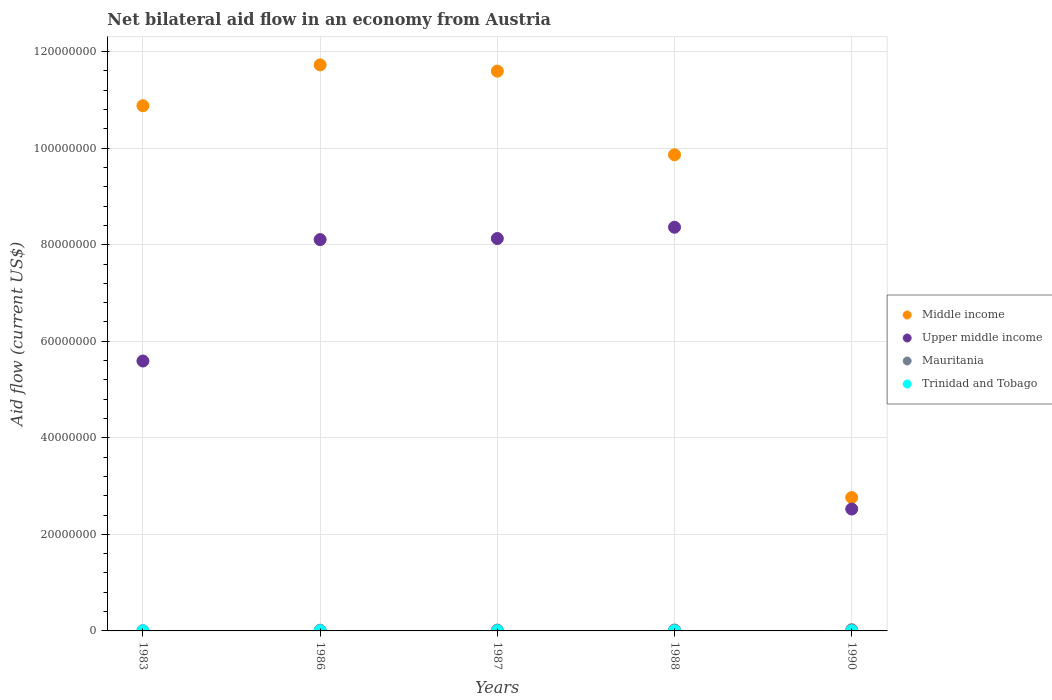How many different coloured dotlines are there?
Your answer should be very brief. 4. Is the number of dotlines equal to the number of legend labels?
Ensure brevity in your answer.  Yes. What is the net bilateral aid flow in Middle income in 1988?
Provide a short and direct response. 9.86e+07. Across all years, what is the maximum net bilateral aid flow in Middle income?
Make the answer very short. 1.17e+08. In which year was the net bilateral aid flow in Upper middle income maximum?
Your answer should be compact. 1988. What is the total net bilateral aid flow in Mauritania in the graph?
Make the answer very short. 8.20e+05. What is the difference between the net bilateral aid flow in Middle income in 1987 and that in 1990?
Provide a succinct answer. 8.83e+07. What is the difference between the net bilateral aid flow in Middle income in 1983 and the net bilateral aid flow in Mauritania in 1987?
Your answer should be very brief. 1.09e+08. What is the average net bilateral aid flow in Trinidad and Tobago per year?
Offer a very short reply. 1.60e+04. In the year 1990, what is the difference between the net bilateral aid flow in Trinidad and Tobago and net bilateral aid flow in Mauritania?
Your answer should be compact. -2.40e+05. What is the ratio of the net bilateral aid flow in Middle income in 1983 to that in 1986?
Make the answer very short. 0.93. Is the difference between the net bilateral aid flow in Trinidad and Tobago in 1987 and 1990 greater than the difference between the net bilateral aid flow in Mauritania in 1987 and 1990?
Offer a very short reply. Yes. What is the difference between the highest and the lowest net bilateral aid flow in Upper middle income?
Offer a very short reply. 5.84e+07. In how many years, is the net bilateral aid flow in Mauritania greater than the average net bilateral aid flow in Mauritania taken over all years?
Your answer should be compact. 3. Is it the case that in every year, the sum of the net bilateral aid flow in Upper middle income and net bilateral aid flow in Mauritania  is greater than the sum of net bilateral aid flow in Trinidad and Tobago and net bilateral aid flow in Middle income?
Offer a very short reply. Yes. Is it the case that in every year, the sum of the net bilateral aid flow in Upper middle income and net bilateral aid flow in Trinidad and Tobago  is greater than the net bilateral aid flow in Mauritania?
Your response must be concise. Yes. Does the net bilateral aid flow in Trinidad and Tobago monotonically increase over the years?
Offer a terse response. No. Is the net bilateral aid flow in Mauritania strictly less than the net bilateral aid flow in Upper middle income over the years?
Give a very brief answer. Yes. How many years are there in the graph?
Keep it short and to the point. 5. Are the values on the major ticks of Y-axis written in scientific E-notation?
Offer a terse response. No. Does the graph contain any zero values?
Provide a succinct answer. No. How many legend labels are there?
Make the answer very short. 4. What is the title of the graph?
Provide a succinct answer. Net bilateral aid flow in an economy from Austria. Does "High income" appear as one of the legend labels in the graph?
Provide a short and direct response. No. What is the label or title of the Y-axis?
Ensure brevity in your answer.  Aid flow (current US$). What is the Aid flow (current US$) in Middle income in 1983?
Your response must be concise. 1.09e+08. What is the Aid flow (current US$) in Upper middle income in 1983?
Ensure brevity in your answer.  5.59e+07. What is the Aid flow (current US$) of Middle income in 1986?
Your answer should be very brief. 1.17e+08. What is the Aid flow (current US$) in Upper middle income in 1986?
Your answer should be very brief. 8.11e+07. What is the Aid flow (current US$) in Mauritania in 1986?
Your answer should be very brief. 1.50e+05. What is the Aid flow (current US$) of Trinidad and Tobago in 1986?
Offer a very short reply. 3.00e+04. What is the Aid flow (current US$) of Middle income in 1987?
Your answer should be compact. 1.16e+08. What is the Aid flow (current US$) of Upper middle income in 1987?
Provide a short and direct response. 8.13e+07. What is the Aid flow (current US$) of Mauritania in 1987?
Ensure brevity in your answer.  1.80e+05. What is the Aid flow (current US$) in Middle income in 1988?
Provide a short and direct response. 9.86e+07. What is the Aid flow (current US$) of Upper middle income in 1988?
Your answer should be very brief. 8.36e+07. What is the Aid flow (current US$) in Mauritania in 1988?
Your answer should be compact. 1.90e+05. What is the Aid flow (current US$) of Trinidad and Tobago in 1988?
Keep it short and to the point. 10000. What is the Aid flow (current US$) of Middle income in 1990?
Give a very brief answer. 2.76e+07. What is the Aid flow (current US$) in Upper middle income in 1990?
Offer a terse response. 2.52e+07. What is the Aid flow (current US$) of Mauritania in 1990?
Keep it short and to the point. 2.50e+05. What is the Aid flow (current US$) of Trinidad and Tobago in 1990?
Your response must be concise. 10000. Across all years, what is the maximum Aid flow (current US$) in Middle income?
Ensure brevity in your answer.  1.17e+08. Across all years, what is the maximum Aid flow (current US$) of Upper middle income?
Your answer should be compact. 8.36e+07. Across all years, what is the maximum Aid flow (current US$) of Mauritania?
Your response must be concise. 2.50e+05. Across all years, what is the minimum Aid flow (current US$) in Middle income?
Offer a terse response. 2.76e+07. Across all years, what is the minimum Aid flow (current US$) of Upper middle income?
Provide a succinct answer. 2.52e+07. Across all years, what is the minimum Aid flow (current US$) in Mauritania?
Your answer should be compact. 5.00e+04. What is the total Aid flow (current US$) of Middle income in the graph?
Give a very brief answer. 4.68e+08. What is the total Aid flow (current US$) in Upper middle income in the graph?
Keep it short and to the point. 3.27e+08. What is the total Aid flow (current US$) in Mauritania in the graph?
Your answer should be very brief. 8.20e+05. What is the total Aid flow (current US$) in Trinidad and Tobago in the graph?
Provide a short and direct response. 8.00e+04. What is the difference between the Aid flow (current US$) in Middle income in 1983 and that in 1986?
Your answer should be very brief. -8.46e+06. What is the difference between the Aid flow (current US$) of Upper middle income in 1983 and that in 1986?
Your answer should be very brief. -2.52e+07. What is the difference between the Aid flow (current US$) in Mauritania in 1983 and that in 1986?
Offer a very short reply. -1.00e+05. What is the difference between the Aid flow (current US$) in Trinidad and Tobago in 1983 and that in 1986?
Give a very brief answer. -2.00e+04. What is the difference between the Aid flow (current US$) in Middle income in 1983 and that in 1987?
Provide a short and direct response. -7.16e+06. What is the difference between the Aid flow (current US$) of Upper middle income in 1983 and that in 1987?
Offer a terse response. -2.54e+07. What is the difference between the Aid flow (current US$) in Trinidad and Tobago in 1983 and that in 1987?
Keep it short and to the point. -10000. What is the difference between the Aid flow (current US$) in Middle income in 1983 and that in 1988?
Keep it short and to the point. 1.02e+07. What is the difference between the Aid flow (current US$) of Upper middle income in 1983 and that in 1988?
Give a very brief answer. -2.77e+07. What is the difference between the Aid flow (current US$) of Mauritania in 1983 and that in 1988?
Your answer should be compact. -1.40e+05. What is the difference between the Aid flow (current US$) in Trinidad and Tobago in 1983 and that in 1988?
Keep it short and to the point. 0. What is the difference between the Aid flow (current US$) in Middle income in 1983 and that in 1990?
Your answer should be compact. 8.12e+07. What is the difference between the Aid flow (current US$) in Upper middle income in 1983 and that in 1990?
Give a very brief answer. 3.07e+07. What is the difference between the Aid flow (current US$) of Mauritania in 1983 and that in 1990?
Give a very brief answer. -2.00e+05. What is the difference between the Aid flow (current US$) of Middle income in 1986 and that in 1987?
Your answer should be compact. 1.30e+06. What is the difference between the Aid flow (current US$) of Upper middle income in 1986 and that in 1987?
Ensure brevity in your answer.  -2.20e+05. What is the difference between the Aid flow (current US$) of Middle income in 1986 and that in 1988?
Your answer should be very brief. 1.86e+07. What is the difference between the Aid flow (current US$) of Upper middle income in 1986 and that in 1988?
Provide a short and direct response. -2.56e+06. What is the difference between the Aid flow (current US$) of Trinidad and Tobago in 1986 and that in 1988?
Offer a very short reply. 2.00e+04. What is the difference between the Aid flow (current US$) of Middle income in 1986 and that in 1990?
Make the answer very short. 8.96e+07. What is the difference between the Aid flow (current US$) in Upper middle income in 1986 and that in 1990?
Keep it short and to the point. 5.58e+07. What is the difference between the Aid flow (current US$) in Trinidad and Tobago in 1986 and that in 1990?
Keep it short and to the point. 2.00e+04. What is the difference between the Aid flow (current US$) in Middle income in 1987 and that in 1988?
Your response must be concise. 1.73e+07. What is the difference between the Aid flow (current US$) of Upper middle income in 1987 and that in 1988?
Give a very brief answer. -2.34e+06. What is the difference between the Aid flow (current US$) of Mauritania in 1987 and that in 1988?
Offer a terse response. -10000. What is the difference between the Aid flow (current US$) of Middle income in 1987 and that in 1990?
Your answer should be compact. 8.83e+07. What is the difference between the Aid flow (current US$) in Upper middle income in 1987 and that in 1990?
Your response must be concise. 5.60e+07. What is the difference between the Aid flow (current US$) in Mauritania in 1987 and that in 1990?
Offer a terse response. -7.00e+04. What is the difference between the Aid flow (current US$) of Trinidad and Tobago in 1987 and that in 1990?
Keep it short and to the point. 10000. What is the difference between the Aid flow (current US$) of Middle income in 1988 and that in 1990?
Offer a very short reply. 7.10e+07. What is the difference between the Aid flow (current US$) in Upper middle income in 1988 and that in 1990?
Keep it short and to the point. 5.84e+07. What is the difference between the Aid flow (current US$) in Mauritania in 1988 and that in 1990?
Your answer should be compact. -6.00e+04. What is the difference between the Aid flow (current US$) in Middle income in 1983 and the Aid flow (current US$) in Upper middle income in 1986?
Ensure brevity in your answer.  2.77e+07. What is the difference between the Aid flow (current US$) of Middle income in 1983 and the Aid flow (current US$) of Mauritania in 1986?
Offer a very short reply. 1.09e+08. What is the difference between the Aid flow (current US$) in Middle income in 1983 and the Aid flow (current US$) in Trinidad and Tobago in 1986?
Make the answer very short. 1.09e+08. What is the difference between the Aid flow (current US$) of Upper middle income in 1983 and the Aid flow (current US$) of Mauritania in 1986?
Your response must be concise. 5.58e+07. What is the difference between the Aid flow (current US$) of Upper middle income in 1983 and the Aid flow (current US$) of Trinidad and Tobago in 1986?
Keep it short and to the point. 5.59e+07. What is the difference between the Aid flow (current US$) in Middle income in 1983 and the Aid flow (current US$) in Upper middle income in 1987?
Give a very brief answer. 2.75e+07. What is the difference between the Aid flow (current US$) of Middle income in 1983 and the Aid flow (current US$) of Mauritania in 1987?
Give a very brief answer. 1.09e+08. What is the difference between the Aid flow (current US$) in Middle income in 1983 and the Aid flow (current US$) in Trinidad and Tobago in 1987?
Provide a succinct answer. 1.09e+08. What is the difference between the Aid flow (current US$) in Upper middle income in 1983 and the Aid flow (current US$) in Mauritania in 1987?
Your answer should be compact. 5.57e+07. What is the difference between the Aid flow (current US$) in Upper middle income in 1983 and the Aid flow (current US$) in Trinidad and Tobago in 1987?
Offer a terse response. 5.59e+07. What is the difference between the Aid flow (current US$) in Mauritania in 1983 and the Aid flow (current US$) in Trinidad and Tobago in 1987?
Provide a short and direct response. 3.00e+04. What is the difference between the Aid flow (current US$) in Middle income in 1983 and the Aid flow (current US$) in Upper middle income in 1988?
Give a very brief answer. 2.52e+07. What is the difference between the Aid flow (current US$) in Middle income in 1983 and the Aid flow (current US$) in Mauritania in 1988?
Provide a succinct answer. 1.09e+08. What is the difference between the Aid flow (current US$) in Middle income in 1983 and the Aid flow (current US$) in Trinidad and Tobago in 1988?
Provide a succinct answer. 1.09e+08. What is the difference between the Aid flow (current US$) of Upper middle income in 1983 and the Aid flow (current US$) of Mauritania in 1988?
Offer a very short reply. 5.57e+07. What is the difference between the Aid flow (current US$) in Upper middle income in 1983 and the Aid flow (current US$) in Trinidad and Tobago in 1988?
Provide a short and direct response. 5.59e+07. What is the difference between the Aid flow (current US$) of Middle income in 1983 and the Aid flow (current US$) of Upper middle income in 1990?
Make the answer very short. 8.35e+07. What is the difference between the Aid flow (current US$) of Middle income in 1983 and the Aid flow (current US$) of Mauritania in 1990?
Keep it short and to the point. 1.09e+08. What is the difference between the Aid flow (current US$) in Middle income in 1983 and the Aid flow (current US$) in Trinidad and Tobago in 1990?
Offer a very short reply. 1.09e+08. What is the difference between the Aid flow (current US$) of Upper middle income in 1983 and the Aid flow (current US$) of Mauritania in 1990?
Offer a terse response. 5.57e+07. What is the difference between the Aid flow (current US$) in Upper middle income in 1983 and the Aid flow (current US$) in Trinidad and Tobago in 1990?
Give a very brief answer. 5.59e+07. What is the difference between the Aid flow (current US$) in Middle income in 1986 and the Aid flow (current US$) in Upper middle income in 1987?
Offer a terse response. 3.60e+07. What is the difference between the Aid flow (current US$) in Middle income in 1986 and the Aid flow (current US$) in Mauritania in 1987?
Your answer should be compact. 1.17e+08. What is the difference between the Aid flow (current US$) in Middle income in 1986 and the Aid flow (current US$) in Trinidad and Tobago in 1987?
Keep it short and to the point. 1.17e+08. What is the difference between the Aid flow (current US$) in Upper middle income in 1986 and the Aid flow (current US$) in Mauritania in 1987?
Provide a succinct answer. 8.09e+07. What is the difference between the Aid flow (current US$) of Upper middle income in 1986 and the Aid flow (current US$) of Trinidad and Tobago in 1987?
Provide a short and direct response. 8.10e+07. What is the difference between the Aid flow (current US$) in Mauritania in 1986 and the Aid flow (current US$) in Trinidad and Tobago in 1987?
Your answer should be very brief. 1.30e+05. What is the difference between the Aid flow (current US$) in Middle income in 1986 and the Aid flow (current US$) in Upper middle income in 1988?
Make the answer very short. 3.36e+07. What is the difference between the Aid flow (current US$) in Middle income in 1986 and the Aid flow (current US$) in Mauritania in 1988?
Provide a succinct answer. 1.17e+08. What is the difference between the Aid flow (current US$) of Middle income in 1986 and the Aid flow (current US$) of Trinidad and Tobago in 1988?
Offer a terse response. 1.17e+08. What is the difference between the Aid flow (current US$) of Upper middle income in 1986 and the Aid flow (current US$) of Mauritania in 1988?
Your answer should be compact. 8.09e+07. What is the difference between the Aid flow (current US$) in Upper middle income in 1986 and the Aid flow (current US$) in Trinidad and Tobago in 1988?
Give a very brief answer. 8.10e+07. What is the difference between the Aid flow (current US$) of Mauritania in 1986 and the Aid flow (current US$) of Trinidad and Tobago in 1988?
Keep it short and to the point. 1.40e+05. What is the difference between the Aid flow (current US$) in Middle income in 1986 and the Aid flow (current US$) in Upper middle income in 1990?
Make the answer very short. 9.20e+07. What is the difference between the Aid flow (current US$) of Middle income in 1986 and the Aid flow (current US$) of Mauritania in 1990?
Your response must be concise. 1.17e+08. What is the difference between the Aid flow (current US$) of Middle income in 1986 and the Aid flow (current US$) of Trinidad and Tobago in 1990?
Ensure brevity in your answer.  1.17e+08. What is the difference between the Aid flow (current US$) in Upper middle income in 1986 and the Aid flow (current US$) in Mauritania in 1990?
Ensure brevity in your answer.  8.08e+07. What is the difference between the Aid flow (current US$) of Upper middle income in 1986 and the Aid flow (current US$) of Trinidad and Tobago in 1990?
Give a very brief answer. 8.10e+07. What is the difference between the Aid flow (current US$) in Mauritania in 1986 and the Aid flow (current US$) in Trinidad and Tobago in 1990?
Offer a terse response. 1.40e+05. What is the difference between the Aid flow (current US$) in Middle income in 1987 and the Aid flow (current US$) in Upper middle income in 1988?
Your response must be concise. 3.23e+07. What is the difference between the Aid flow (current US$) of Middle income in 1987 and the Aid flow (current US$) of Mauritania in 1988?
Offer a very short reply. 1.16e+08. What is the difference between the Aid flow (current US$) in Middle income in 1987 and the Aid flow (current US$) in Trinidad and Tobago in 1988?
Keep it short and to the point. 1.16e+08. What is the difference between the Aid flow (current US$) of Upper middle income in 1987 and the Aid flow (current US$) of Mauritania in 1988?
Give a very brief answer. 8.11e+07. What is the difference between the Aid flow (current US$) of Upper middle income in 1987 and the Aid flow (current US$) of Trinidad and Tobago in 1988?
Provide a succinct answer. 8.13e+07. What is the difference between the Aid flow (current US$) of Mauritania in 1987 and the Aid flow (current US$) of Trinidad and Tobago in 1988?
Ensure brevity in your answer.  1.70e+05. What is the difference between the Aid flow (current US$) in Middle income in 1987 and the Aid flow (current US$) in Upper middle income in 1990?
Keep it short and to the point. 9.07e+07. What is the difference between the Aid flow (current US$) of Middle income in 1987 and the Aid flow (current US$) of Mauritania in 1990?
Keep it short and to the point. 1.16e+08. What is the difference between the Aid flow (current US$) of Middle income in 1987 and the Aid flow (current US$) of Trinidad and Tobago in 1990?
Make the answer very short. 1.16e+08. What is the difference between the Aid flow (current US$) in Upper middle income in 1987 and the Aid flow (current US$) in Mauritania in 1990?
Provide a succinct answer. 8.10e+07. What is the difference between the Aid flow (current US$) of Upper middle income in 1987 and the Aid flow (current US$) of Trinidad and Tobago in 1990?
Provide a succinct answer. 8.13e+07. What is the difference between the Aid flow (current US$) in Middle income in 1988 and the Aid flow (current US$) in Upper middle income in 1990?
Your answer should be compact. 7.34e+07. What is the difference between the Aid flow (current US$) of Middle income in 1988 and the Aid flow (current US$) of Mauritania in 1990?
Ensure brevity in your answer.  9.84e+07. What is the difference between the Aid flow (current US$) of Middle income in 1988 and the Aid flow (current US$) of Trinidad and Tobago in 1990?
Your response must be concise. 9.86e+07. What is the difference between the Aid flow (current US$) of Upper middle income in 1988 and the Aid flow (current US$) of Mauritania in 1990?
Provide a succinct answer. 8.34e+07. What is the difference between the Aid flow (current US$) of Upper middle income in 1988 and the Aid flow (current US$) of Trinidad and Tobago in 1990?
Keep it short and to the point. 8.36e+07. What is the difference between the Aid flow (current US$) of Mauritania in 1988 and the Aid flow (current US$) of Trinidad and Tobago in 1990?
Keep it short and to the point. 1.80e+05. What is the average Aid flow (current US$) in Middle income per year?
Provide a succinct answer. 9.36e+07. What is the average Aid flow (current US$) in Upper middle income per year?
Offer a terse response. 6.54e+07. What is the average Aid flow (current US$) in Mauritania per year?
Your response must be concise. 1.64e+05. What is the average Aid flow (current US$) of Trinidad and Tobago per year?
Offer a very short reply. 1.60e+04. In the year 1983, what is the difference between the Aid flow (current US$) in Middle income and Aid flow (current US$) in Upper middle income?
Ensure brevity in your answer.  5.29e+07. In the year 1983, what is the difference between the Aid flow (current US$) in Middle income and Aid flow (current US$) in Mauritania?
Make the answer very short. 1.09e+08. In the year 1983, what is the difference between the Aid flow (current US$) in Middle income and Aid flow (current US$) in Trinidad and Tobago?
Your answer should be very brief. 1.09e+08. In the year 1983, what is the difference between the Aid flow (current US$) of Upper middle income and Aid flow (current US$) of Mauritania?
Keep it short and to the point. 5.59e+07. In the year 1983, what is the difference between the Aid flow (current US$) of Upper middle income and Aid flow (current US$) of Trinidad and Tobago?
Your response must be concise. 5.59e+07. In the year 1983, what is the difference between the Aid flow (current US$) of Mauritania and Aid flow (current US$) of Trinidad and Tobago?
Your answer should be compact. 4.00e+04. In the year 1986, what is the difference between the Aid flow (current US$) of Middle income and Aid flow (current US$) of Upper middle income?
Provide a succinct answer. 3.62e+07. In the year 1986, what is the difference between the Aid flow (current US$) of Middle income and Aid flow (current US$) of Mauritania?
Your answer should be very brief. 1.17e+08. In the year 1986, what is the difference between the Aid flow (current US$) in Middle income and Aid flow (current US$) in Trinidad and Tobago?
Keep it short and to the point. 1.17e+08. In the year 1986, what is the difference between the Aid flow (current US$) of Upper middle income and Aid flow (current US$) of Mauritania?
Ensure brevity in your answer.  8.09e+07. In the year 1986, what is the difference between the Aid flow (current US$) in Upper middle income and Aid flow (current US$) in Trinidad and Tobago?
Your answer should be compact. 8.10e+07. In the year 1987, what is the difference between the Aid flow (current US$) in Middle income and Aid flow (current US$) in Upper middle income?
Give a very brief answer. 3.47e+07. In the year 1987, what is the difference between the Aid flow (current US$) in Middle income and Aid flow (current US$) in Mauritania?
Provide a succinct answer. 1.16e+08. In the year 1987, what is the difference between the Aid flow (current US$) in Middle income and Aid flow (current US$) in Trinidad and Tobago?
Provide a short and direct response. 1.16e+08. In the year 1987, what is the difference between the Aid flow (current US$) of Upper middle income and Aid flow (current US$) of Mauritania?
Provide a succinct answer. 8.11e+07. In the year 1987, what is the difference between the Aid flow (current US$) of Upper middle income and Aid flow (current US$) of Trinidad and Tobago?
Offer a very short reply. 8.13e+07. In the year 1988, what is the difference between the Aid flow (current US$) in Middle income and Aid flow (current US$) in Upper middle income?
Ensure brevity in your answer.  1.50e+07. In the year 1988, what is the difference between the Aid flow (current US$) in Middle income and Aid flow (current US$) in Mauritania?
Your answer should be compact. 9.84e+07. In the year 1988, what is the difference between the Aid flow (current US$) of Middle income and Aid flow (current US$) of Trinidad and Tobago?
Make the answer very short. 9.86e+07. In the year 1988, what is the difference between the Aid flow (current US$) in Upper middle income and Aid flow (current US$) in Mauritania?
Keep it short and to the point. 8.34e+07. In the year 1988, what is the difference between the Aid flow (current US$) of Upper middle income and Aid flow (current US$) of Trinidad and Tobago?
Offer a very short reply. 8.36e+07. In the year 1988, what is the difference between the Aid flow (current US$) in Mauritania and Aid flow (current US$) in Trinidad and Tobago?
Ensure brevity in your answer.  1.80e+05. In the year 1990, what is the difference between the Aid flow (current US$) of Middle income and Aid flow (current US$) of Upper middle income?
Keep it short and to the point. 2.38e+06. In the year 1990, what is the difference between the Aid flow (current US$) of Middle income and Aid flow (current US$) of Mauritania?
Keep it short and to the point. 2.74e+07. In the year 1990, what is the difference between the Aid flow (current US$) of Middle income and Aid flow (current US$) of Trinidad and Tobago?
Your answer should be very brief. 2.76e+07. In the year 1990, what is the difference between the Aid flow (current US$) in Upper middle income and Aid flow (current US$) in Mauritania?
Offer a very short reply. 2.50e+07. In the year 1990, what is the difference between the Aid flow (current US$) of Upper middle income and Aid flow (current US$) of Trinidad and Tobago?
Make the answer very short. 2.52e+07. What is the ratio of the Aid flow (current US$) of Middle income in 1983 to that in 1986?
Offer a very short reply. 0.93. What is the ratio of the Aid flow (current US$) of Upper middle income in 1983 to that in 1986?
Offer a very short reply. 0.69. What is the ratio of the Aid flow (current US$) in Mauritania in 1983 to that in 1986?
Offer a terse response. 0.33. What is the ratio of the Aid flow (current US$) of Middle income in 1983 to that in 1987?
Provide a succinct answer. 0.94. What is the ratio of the Aid flow (current US$) in Upper middle income in 1983 to that in 1987?
Provide a short and direct response. 0.69. What is the ratio of the Aid flow (current US$) in Mauritania in 1983 to that in 1987?
Provide a succinct answer. 0.28. What is the ratio of the Aid flow (current US$) of Middle income in 1983 to that in 1988?
Provide a short and direct response. 1.1. What is the ratio of the Aid flow (current US$) of Upper middle income in 1983 to that in 1988?
Your answer should be very brief. 0.67. What is the ratio of the Aid flow (current US$) of Mauritania in 1983 to that in 1988?
Offer a terse response. 0.26. What is the ratio of the Aid flow (current US$) of Middle income in 1983 to that in 1990?
Your answer should be compact. 3.94. What is the ratio of the Aid flow (current US$) in Upper middle income in 1983 to that in 1990?
Offer a terse response. 2.21. What is the ratio of the Aid flow (current US$) in Mauritania in 1983 to that in 1990?
Keep it short and to the point. 0.2. What is the ratio of the Aid flow (current US$) of Middle income in 1986 to that in 1987?
Your response must be concise. 1.01. What is the ratio of the Aid flow (current US$) of Trinidad and Tobago in 1986 to that in 1987?
Your response must be concise. 1.5. What is the ratio of the Aid flow (current US$) in Middle income in 1986 to that in 1988?
Offer a very short reply. 1.19. What is the ratio of the Aid flow (current US$) in Upper middle income in 1986 to that in 1988?
Provide a succinct answer. 0.97. What is the ratio of the Aid flow (current US$) of Mauritania in 1986 to that in 1988?
Your response must be concise. 0.79. What is the ratio of the Aid flow (current US$) in Middle income in 1986 to that in 1990?
Your answer should be compact. 4.24. What is the ratio of the Aid flow (current US$) of Upper middle income in 1986 to that in 1990?
Keep it short and to the point. 3.21. What is the ratio of the Aid flow (current US$) in Mauritania in 1986 to that in 1990?
Your response must be concise. 0.6. What is the ratio of the Aid flow (current US$) of Middle income in 1987 to that in 1988?
Your answer should be compact. 1.18. What is the ratio of the Aid flow (current US$) in Middle income in 1987 to that in 1990?
Ensure brevity in your answer.  4.2. What is the ratio of the Aid flow (current US$) of Upper middle income in 1987 to that in 1990?
Your answer should be very brief. 3.22. What is the ratio of the Aid flow (current US$) in Mauritania in 1987 to that in 1990?
Offer a terse response. 0.72. What is the ratio of the Aid flow (current US$) of Trinidad and Tobago in 1987 to that in 1990?
Your answer should be compact. 2. What is the ratio of the Aid flow (current US$) in Middle income in 1988 to that in 1990?
Provide a succinct answer. 3.57. What is the ratio of the Aid flow (current US$) in Upper middle income in 1988 to that in 1990?
Offer a very short reply. 3.31. What is the ratio of the Aid flow (current US$) of Mauritania in 1988 to that in 1990?
Your response must be concise. 0.76. What is the difference between the highest and the second highest Aid flow (current US$) in Middle income?
Keep it short and to the point. 1.30e+06. What is the difference between the highest and the second highest Aid flow (current US$) of Upper middle income?
Offer a very short reply. 2.34e+06. What is the difference between the highest and the second highest Aid flow (current US$) in Mauritania?
Your answer should be compact. 6.00e+04. What is the difference between the highest and the lowest Aid flow (current US$) in Middle income?
Ensure brevity in your answer.  8.96e+07. What is the difference between the highest and the lowest Aid flow (current US$) in Upper middle income?
Provide a succinct answer. 5.84e+07. What is the difference between the highest and the lowest Aid flow (current US$) of Mauritania?
Offer a very short reply. 2.00e+05. What is the difference between the highest and the lowest Aid flow (current US$) of Trinidad and Tobago?
Provide a succinct answer. 2.00e+04. 